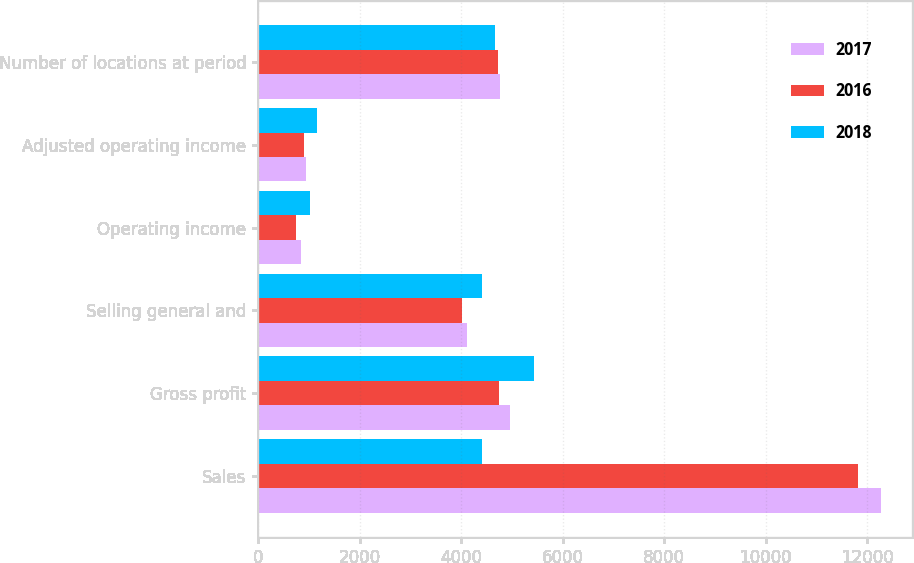<chart> <loc_0><loc_0><loc_500><loc_500><stacked_bar_chart><ecel><fcel>Sales<fcel>Gross profit<fcel>Selling general and<fcel>Operating income<fcel>Adjusted operating income<fcel>Number of locations at period<nl><fcel>2017<fcel>12281<fcel>4958<fcel>4116<fcel>842<fcel>947<fcel>4767<nl><fcel>2016<fcel>11813<fcel>4753<fcel>4012<fcel>741<fcel>909<fcel>4722<nl><fcel>2018<fcel>4403<fcel>5432<fcel>4403<fcel>1029<fcel>1155<fcel>4673<nl></chart> 